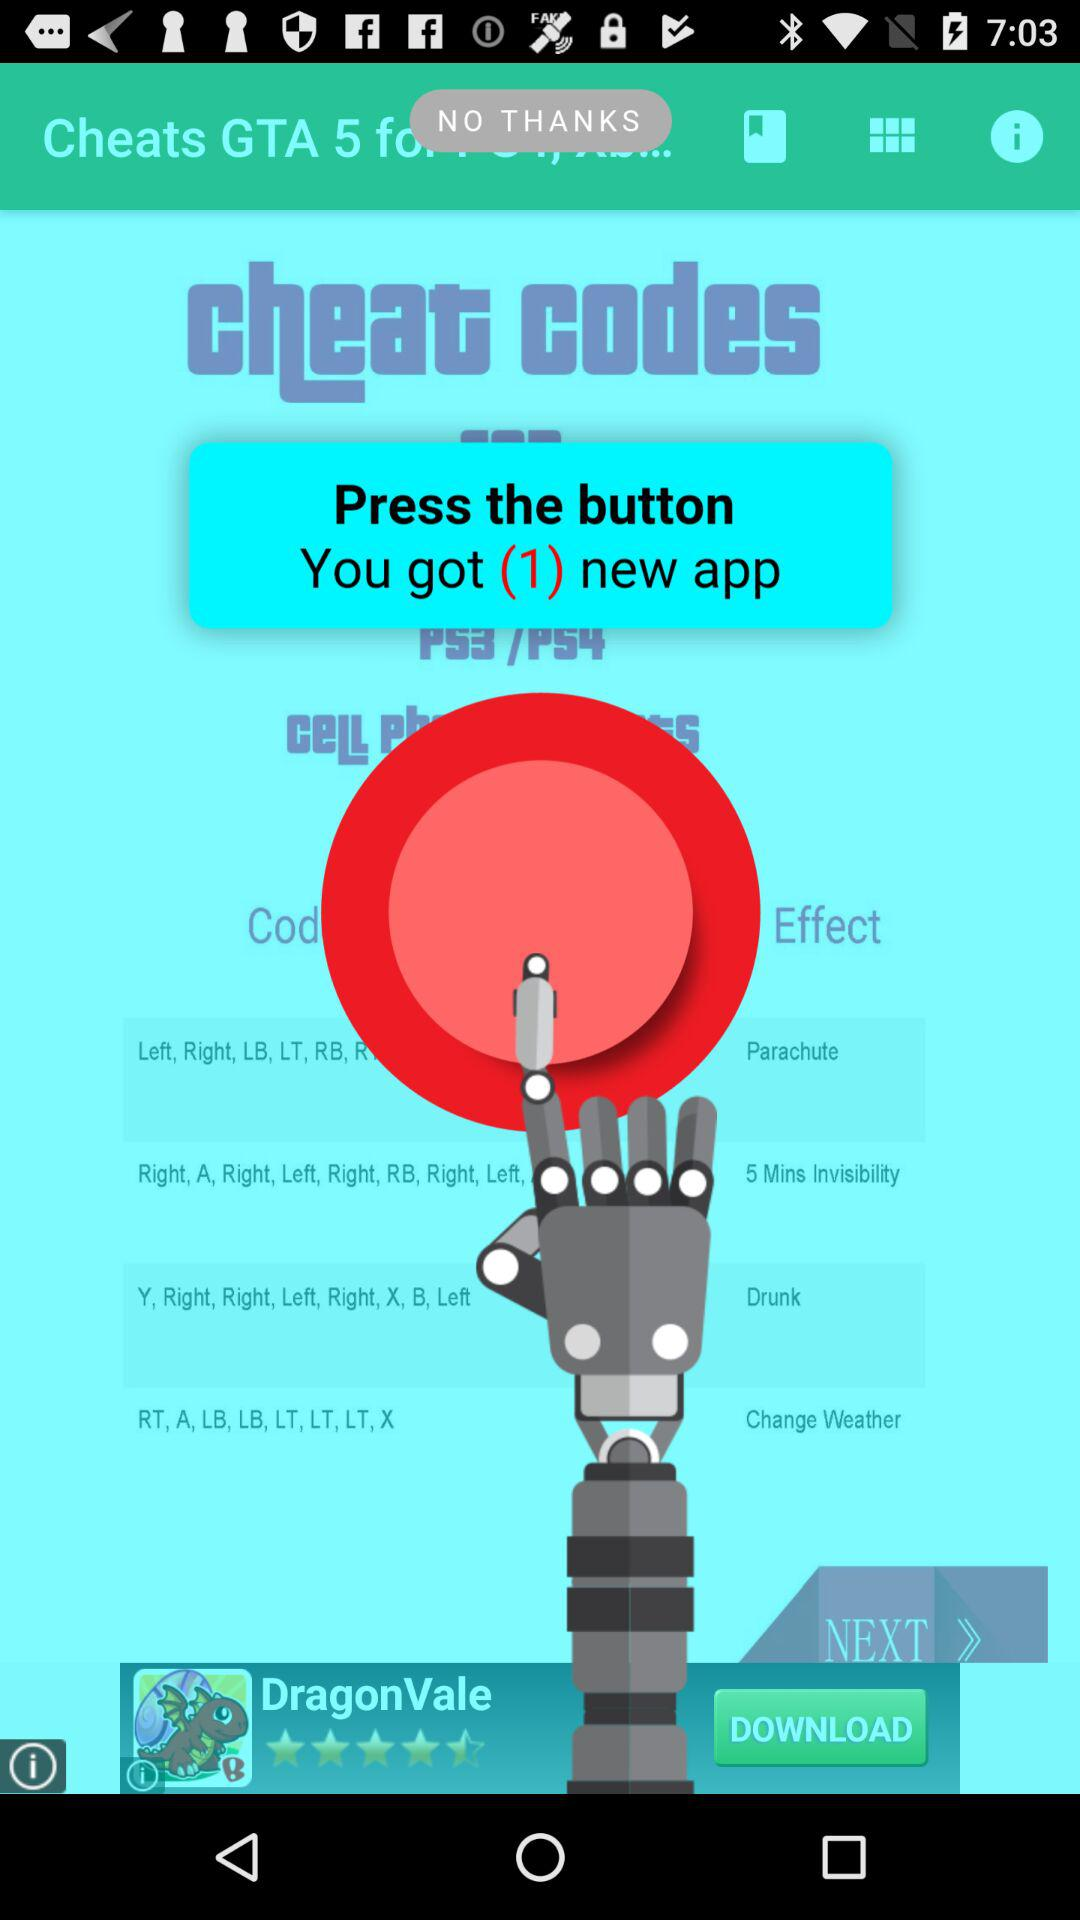How many new apps have I got after pressing the button? You got 1 new app. 